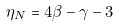<formula> <loc_0><loc_0><loc_500><loc_500>\eta _ { N } = 4 \beta - \gamma - 3</formula> 